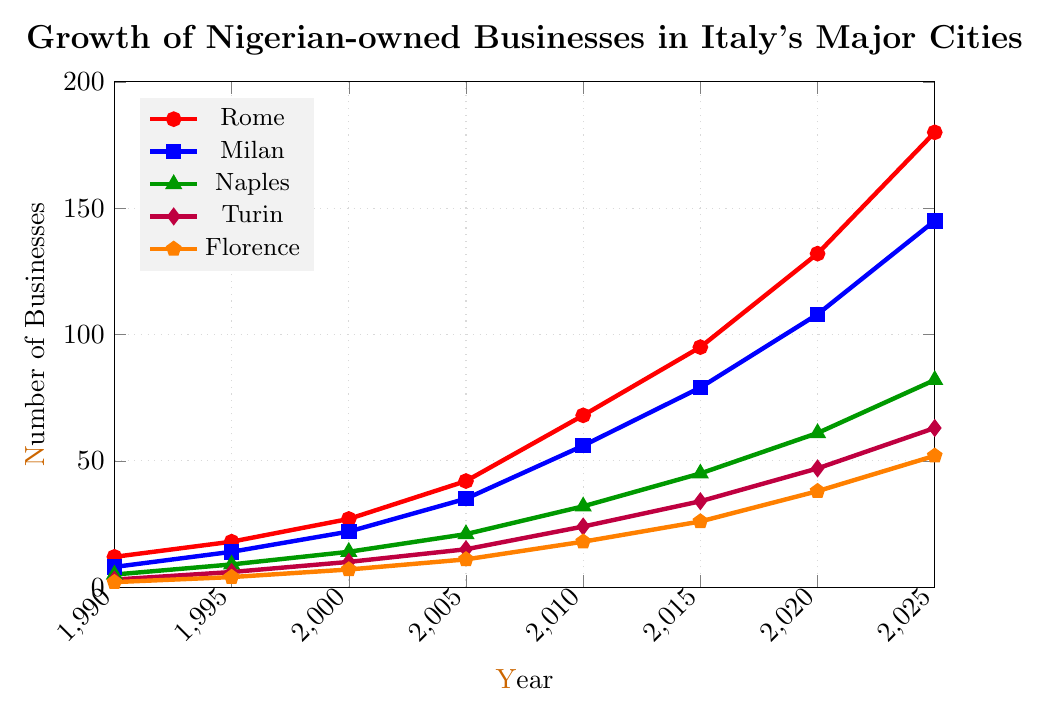Which city shows the most significant increase in Nigerian-owned businesses from 1990 to 2025? Look at the starting (1990) and ending (2025) points for each city and calculate the difference. Rome increases from 12 to 180 (an increase of 168), Milan from 8 to 145 (137), Naples from 5 to 82 (77), Turin from 3 to 63 (60), and Florence from 2 to 52 (50). The largest increase is in Rome.
Answer: Rome Which city had more Nigerian-owned businesses in 2020, Milan or Naples? From the data points at 2020 for Milan and Naples, Milan had 108 businesses and Naples had 61 businesses. Thus, Milan had more businesses.
Answer: Milan What is the total number of Nigerian-owned businesses across all cities in 2010? Sum the number of businesses in each city for the year 2010: 68 (Rome) + 56 (Milan) + 32 (Naples) + 24 (Turin) + 18 (Florence) = 198.
Answer: 198 Which city had the smallest number of Nigerian-owned businesses in 1995? From the data points for 1995, Florence had 4 businesses, which is the smallest compared to Rome (18), Milan (14), Naples (9), and Turin (6).
Answer: Florence In which year did Rome have twice as many Nigerian-owned businesses as Naples? Check when Rome's count is approximately double Naples' count by comparing data points. In 2005, Rome had 42 businesses, while Naples had 21, exactly double.
Answer: 2005 By how much did the number of Nigerian-owned businesses in Turin increase between 2005 and 2025? Subtract the 2005 value from the 2025 value for Turin: 63 (2025) - 15 (2005) = 48.
Answer: 48 How does the growth trend of Nigerian-owned businesses in Florence compare with that in Naples from 1990 to 2025? Compare the slopes of the growth in the number of businesses. Florence increased from 2 to 52 (increase of 50), and Naples increased from 5 to 82 (increase of 77). Naples had a higher increase, indicating a steeper trend.
Answer: Naples had a higher growth trend What is the average number of Nigerian-owned businesses in Rome from 2000 to 2010? Add the values from 2000, 2005, and 2010, and divide by the number of years: (27 + 42 + 68) / 3 = 137 / 3 ≈ 45.7.
Answer: Approximately 45.7 Which city had the highest growth rate between 2000 and 2020? Calculate the growth rate for each city and compare. Rome: (132-27)/27, Milan: (108-22)/22, Naples: (61-14)/14, Turin: (47-10)/10, Florence: (38-7)/7. Rome's growth rate is highest.
Answer: Rome By what percentage did the number of Nigerian-owned businesses in Milan increase from 1990 to 2000? Calculate the percentage increase: [(22 - 8) / 8] * 100 = 175%.
Answer: 175% 